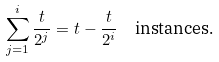<formula> <loc_0><loc_0><loc_500><loc_500>& & \sum _ { j = 1 } ^ { i } \frac { t } { 2 ^ { j } } = t - \frac { t } { 2 ^ { i } } \text {\quad instances.}</formula> 